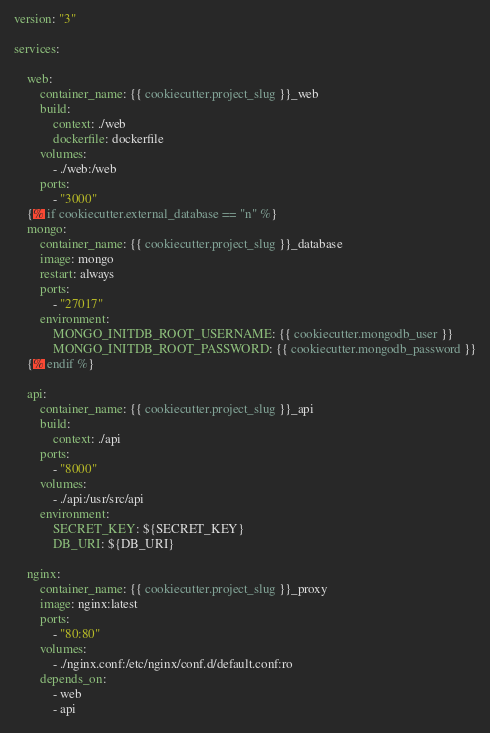Convert code to text. <code><loc_0><loc_0><loc_500><loc_500><_YAML_>version: "3"

services:

    web:
        container_name: {{ cookiecutter.project_slug }}_web
        build:
            context: ./web
            dockerfile: dockerfile
        volumes:
            - ./web:/web
        ports:
            - "3000"
    {% if cookiecutter.external_database == "n" %}
    mongo:
        container_name: {{ cookiecutter.project_slug }}_database
        image: mongo
        restart: always
        ports:
            - "27017"
        environment:
            MONGO_INITDB_ROOT_USERNAME: {{ cookiecutter.mongodb_user }}
            MONGO_INITDB_ROOT_PASSWORD: {{ cookiecutter.mongodb_password }}
    {% endif %}

    api:
        container_name: {{ cookiecutter.project_slug }}_api
        build:
            context: ./api
        ports:
            - "8000"
        volumes: 
            - ./api:/usr/src/api
        environment:
            SECRET_KEY: ${SECRET_KEY}
            DB_URI: ${DB_URI}

    nginx:
        container_name: {{ cookiecutter.project_slug }}_proxy
        image: nginx:latest
        ports:
            - "80:80"
        volumes:
            - ./nginx.conf:/etc/nginx/conf.d/default.conf:ro
        depends_on:
            - web
            - api
</code> 